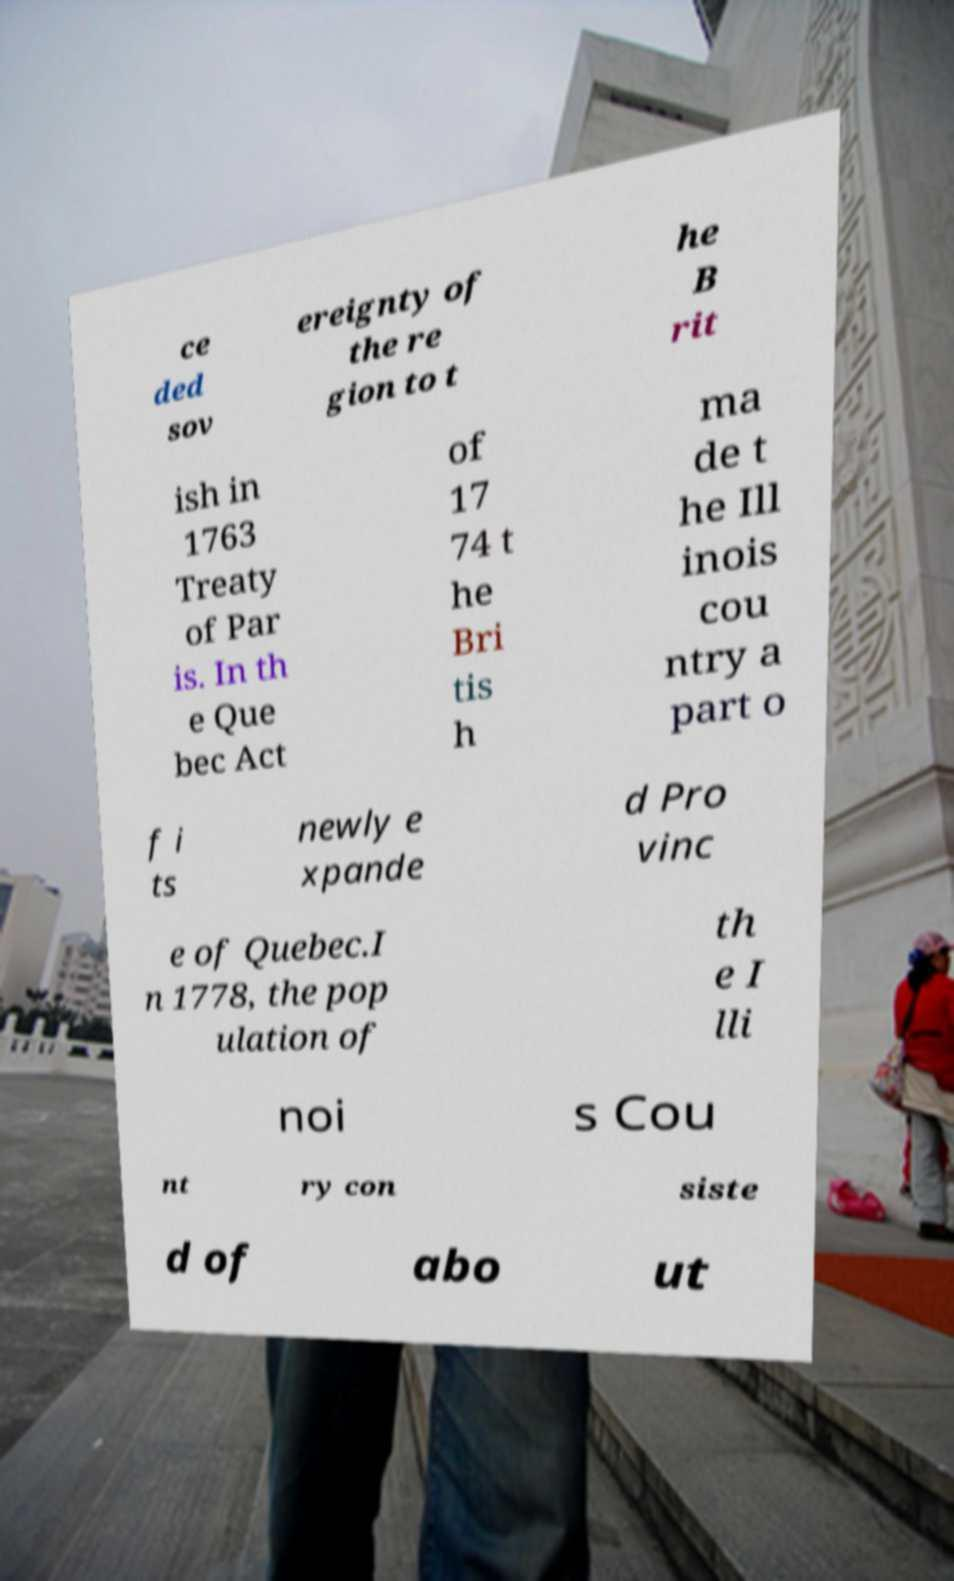Could you assist in decoding the text presented in this image and type it out clearly? ce ded sov ereignty of the re gion to t he B rit ish in 1763 Treaty of Par is. In th e Que bec Act of 17 74 t he Bri tis h ma de t he Ill inois cou ntry a part o f i ts newly e xpande d Pro vinc e of Quebec.I n 1778, the pop ulation of th e I lli noi s Cou nt ry con siste d of abo ut 